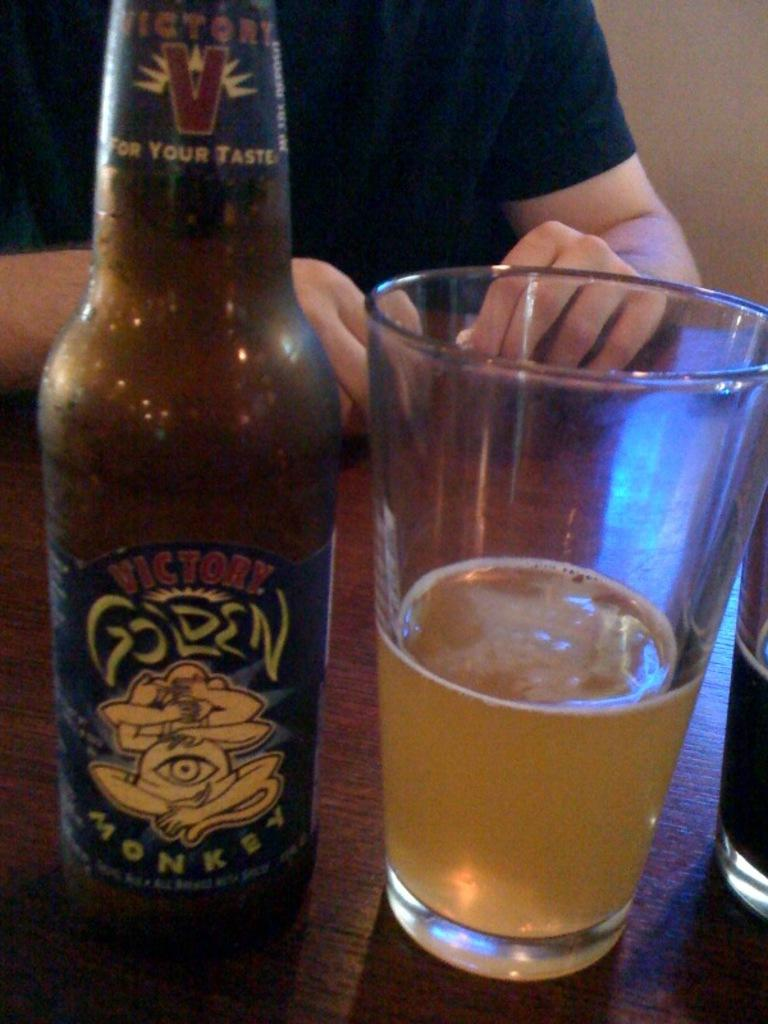<image>
Render a clear and concise summary of the photo. A bottle of Victory Golden Monkey beer sits next to a glass. 